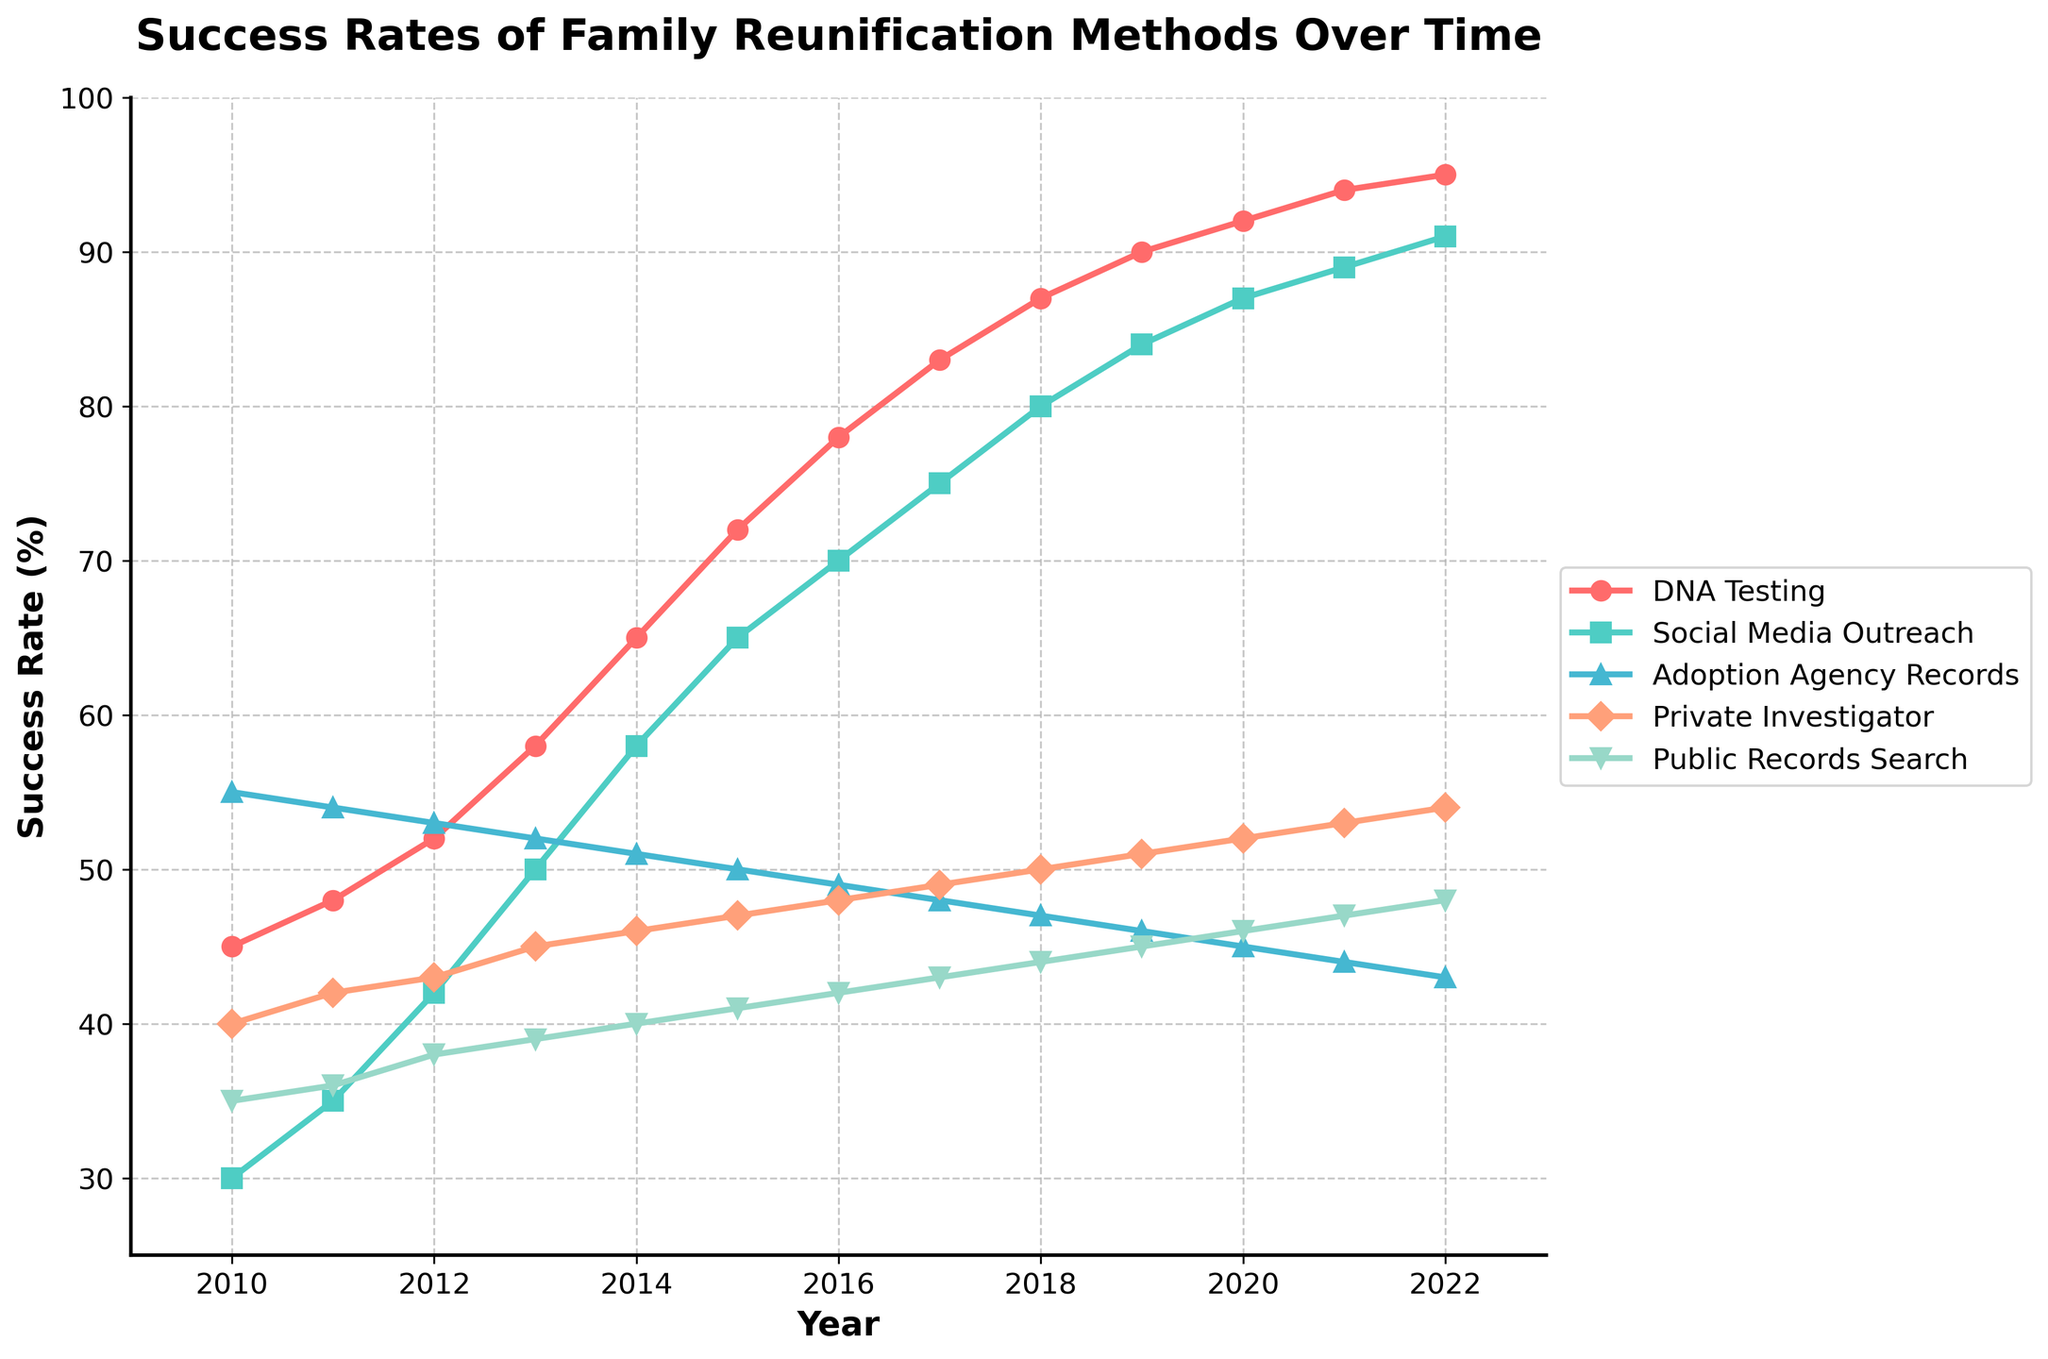Which search method saw the highest increase in success rate from 2010 to 2022? To find this, we need to calculate the difference in success rates from 2010 to 2022 for each method and compare them. DNA Testing: 95-45 = 50, Social Media Outreach: 91-30 = 61, Adoption Agency Records: 43-55 = -12, Private Investigator: 54-40 = 14, Public Records Search: 48-35 = 13. Social Media Outreach has the highest increase of 61.
Answer: Social Media Outreach By how many percentage points did the success rate for Public Records Search increase from 2010 to 2022? To determine the increase, subtract the 2010 success rate from the 2022 success rate. 48% (2022) - 35% (2010) = 13 percentage points.
Answer: 13 Between which years did Social Media Outreach see the largest yearly increase in success rate? We calculate the yearly increase for each pair of consecutive years and identify the maximum. From 2012 to 2013: 50-42 = 8, and other increases are smaller.
Answer: 2012 to 2013 What was the average success rate of DNA Testing from 2010 to 2022? To find the average, sum the success rates for each year and divide by the number of years: (45+48+52+58+65+72+78+83+87+90+92+94+95)/13 = 70.7%.
Answer: 70.7 Which method consistently outperformed Public Records Search every year? By comparing the success rates year by year, we see that Adoption Agency Records consistently has higher rates than Public Records Search.
Answer: Adoption Agency Records Did any search method show a declining trend in success rates over the period 2010 to 2022? Reviewing the trends for each method, Adoption Agency Records showed a decline from 55% in 2010 to 43% in 2022.
Answer: Adoption Agency Records What was the success rate of Private Investigator in 2015, and how does it compare to the rate in 2020? The success rate in 2015 was 47%, and in 2020 it was 52%. To compare, 52% - 47% = 5%.
Answer: 5 percentage points higher Which search method had the closest success rate to 50% in 2013? By examining the success rates in 2013: DNA Testing 58, Social Media Outreach 50, Adoption Agency Records 52, Private Investigator 45, Public Records Search 39. Social Media Outreach had a success rate of exactly 50%.
Answer: Social Media Outreach How many years took for DNA Testing to increase its success rate from 45% to over 90%? DNA Testing achieved a success rate above 90% in 2019 starting from 45% in 2010. It took 9 years (from 2010 to 2019).
Answer: 9 years 